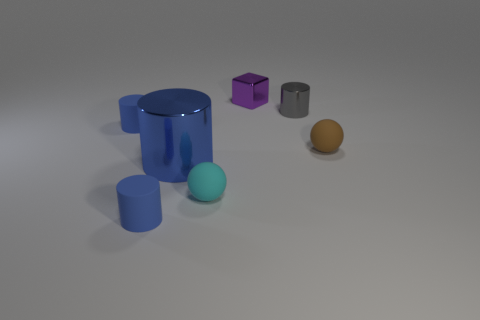Are there any small blue rubber things?
Your answer should be very brief. Yes. What is the sphere that is to the right of the gray metallic cylinder behind the blue rubber thing that is behind the small cyan matte sphere made of?
Your answer should be compact. Rubber. Is the shape of the tiny gray thing the same as the tiny blue matte object that is in front of the tiny brown thing?
Make the answer very short. Yes. What number of other small things have the same shape as the small purple thing?
Provide a succinct answer. 0. The purple object is what shape?
Ensure brevity in your answer.  Cube. What size is the rubber sphere that is left of the tiny metal thing in front of the small purple thing?
Ensure brevity in your answer.  Small. How many things are either big blue metallic cylinders or brown metal spheres?
Ensure brevity in your answer.  1. Is the brown object the same shape as the purple metal thing?
Your response must be concise. No. Is there a blue object made of the same material as the small purple thing?
Keep it short and to the point. Yes. There is a small metal object that is to the right of the shiny block; are there any purple shiny things in front of it?
Give a very brief answer. No. 